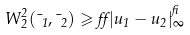Convert formula to latex. <formula><loc_0><loc_0><loc_500><loc_500>W _ { 2 } ^ { 2 } ( \mu _ { 1 } , \mu _ { 2 } ) \geqslant \alpha | u _ { 1 } - u _ { 2 } | _ { \infty } ^ { \beta }</formula> 